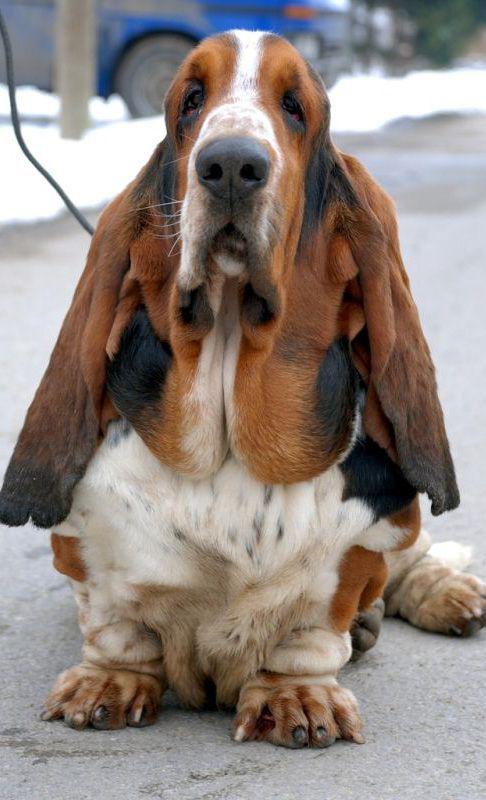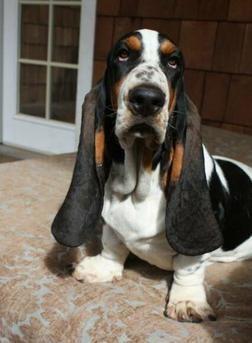The first image is the image on the left, the second image is the image on the right. Examine the images to the left and right. Is the description "In one image there is two basset hounds outside standing on a brick walkway." accurate? Answer yes or no. No. The first image is the image on the left, the second image is the image on the right. Analyze the images presented: Is the assertion "There are at most two dogs." valid? Answer yes or no. Yes. 